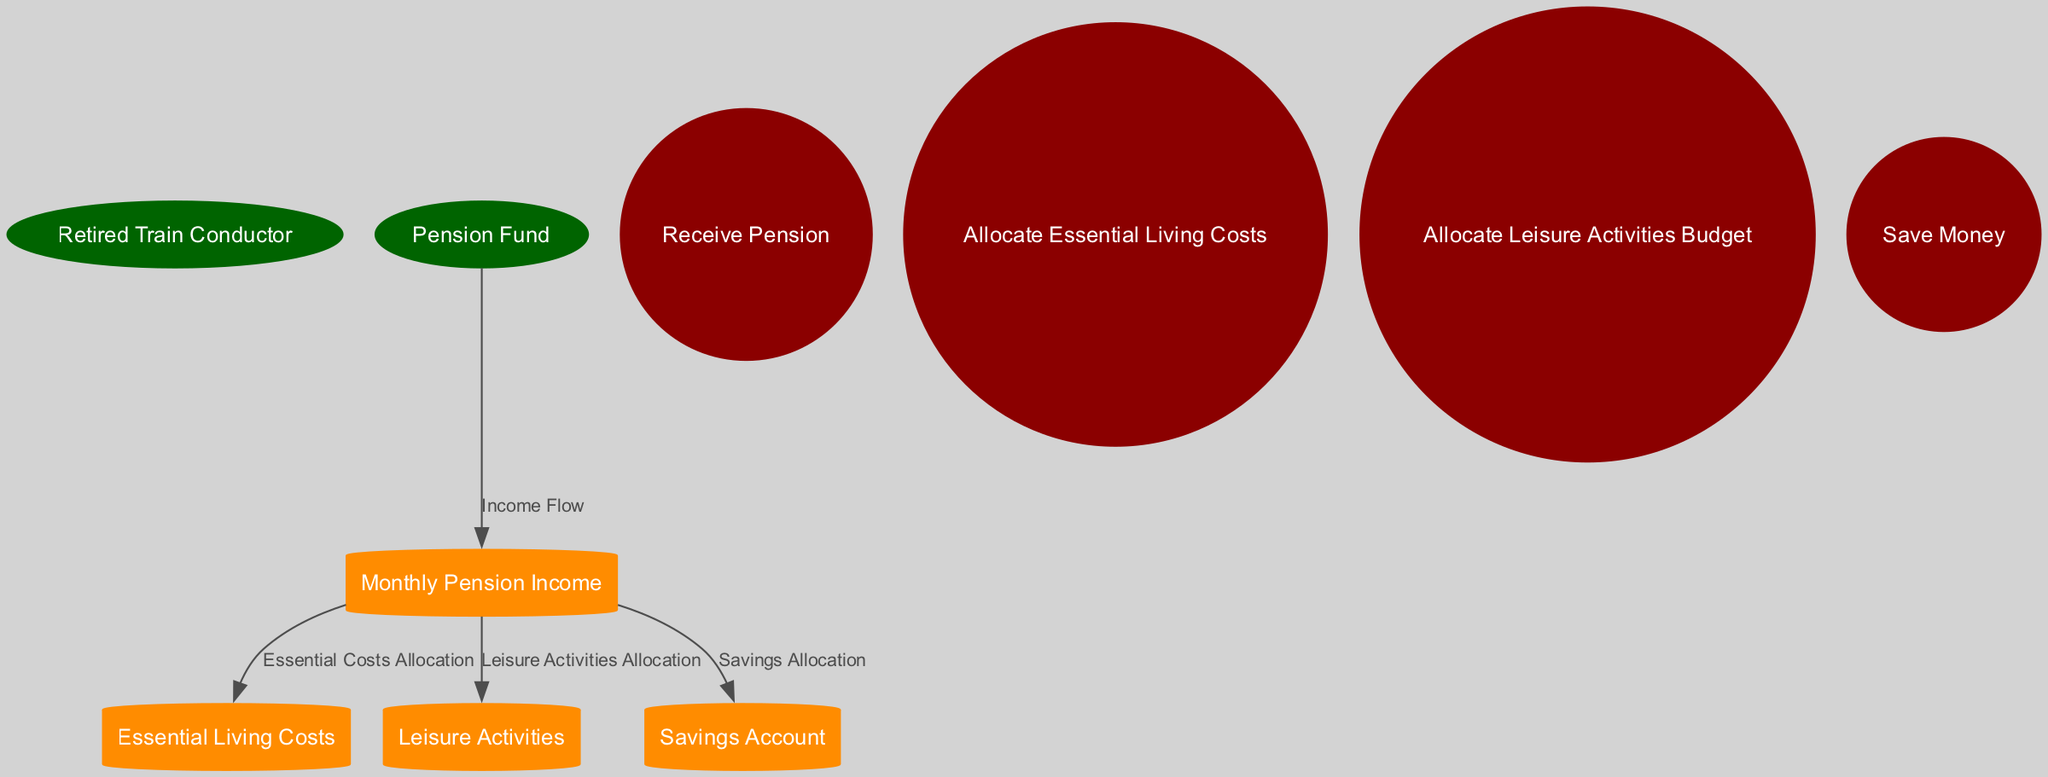What is the total number of data stores in the diagram? The diagram contains four data stores: Monthly Pension Income, Essential Living Costs, Leisure Activities, and Savings Account.
Answer: 4 Who is the source of the pension income? The Pension Fund provides the pension income to the Retired Train Conductor.
Answer: Pension Fund What type of entity is the Retired Train Conductor? The Retired Train Conductor is categorized as an external entity, which means it represents an entity from outside the system that interacts with internal components.
Answer: External Entity Which process is responsible for allocating funds for essential living costs? The process named "Allocate Essential Living Costs" is specifically tasked with moving funds from the Monthly Pension Income to the Essential Living Costs data store.
Answer: Allocate Essential Living Costs What do the essential living costs represent? Essential Living Costs is a data store used to keep track of expenses related to essential items such as food, utilities, and housing.
Answer: Essential Costs Which flow connects the Pension Fund to the Monthly Pension Income? The flow known as "Income Flow" describes the movement of pension income from the Pension Fund directly to the Monthly Pension Income data store.
Answer: Income Flow How many processes are there in total? There are four processes in the diagram: Receive Pension, Allocate Essential Living Costs, Allocate Leisure Activities Budget, and Save Money.
Answer: 4 What is the end result for funds after the completion of all processes? The remaining funds from the Monthly Pension Income are transferred to the Savings Account after allocations for living costs and leisure activities.
Answer: Savings Account Which type of entities are the data stores? The data stores in the diagram are categorized as data repositories, which serve to retain financial information regarding income and expenses.
Answer: Data Stores 